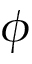<formula> <loc_0><loc_0><loc_500><loc_500>\phi</formula> 